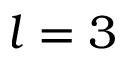Convert formula to latex. <formula><loc_0><loc_0><loc_500><loc_500>l = 3</formula> 